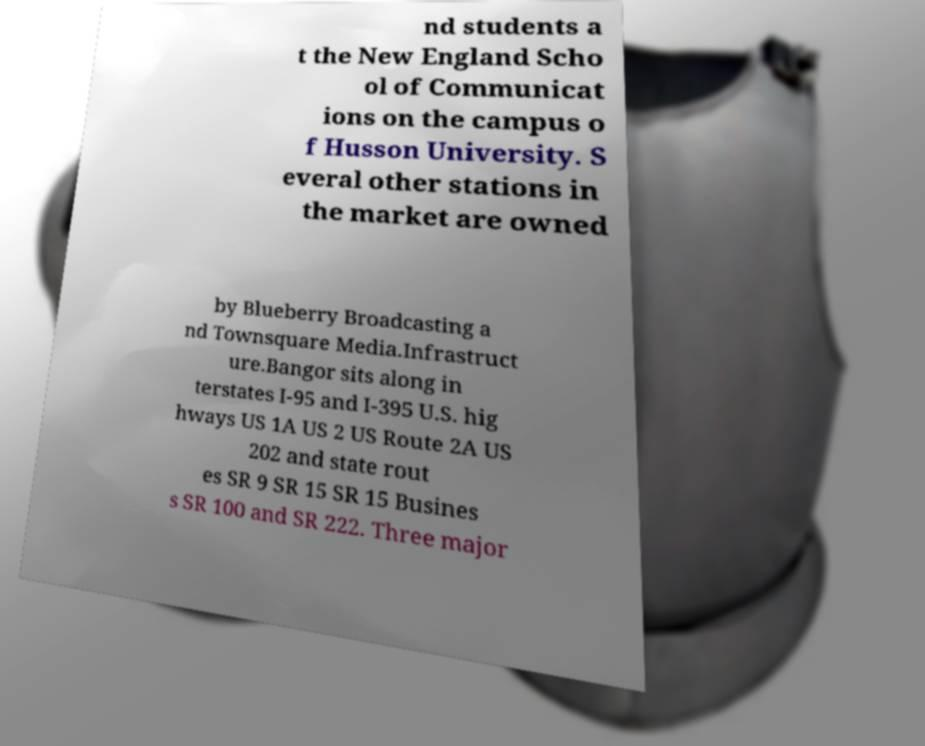Can you read and provide the text displayed in the image?This photo seems to have some interesting text. Can you extract and type it out for me? nd students a t the New England Scho ol of Communicat ions on the campus o f Husson University. S everal other stations in the market are owned by Blueberry Broadcasting a nd Townsquare Media.Infrastruct ure.Bangor sits along in terstates I-95 and I-395 U.S. hig hways US 1A US 2 US Route 2A US 202 and state rout es SR 9 SR 15 SR 15 Busines s SR 100 and SR 222. Three major 